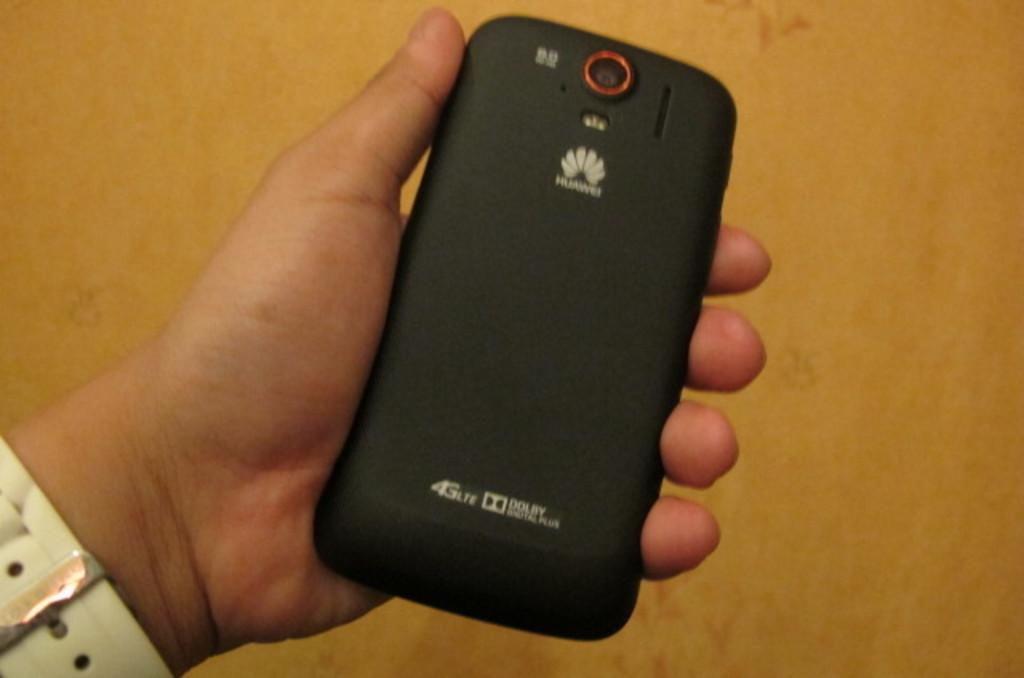<image>
Write a terse but informative summary of the picture. A phone that has 4G lite and Dolby ability is being held by a person. 